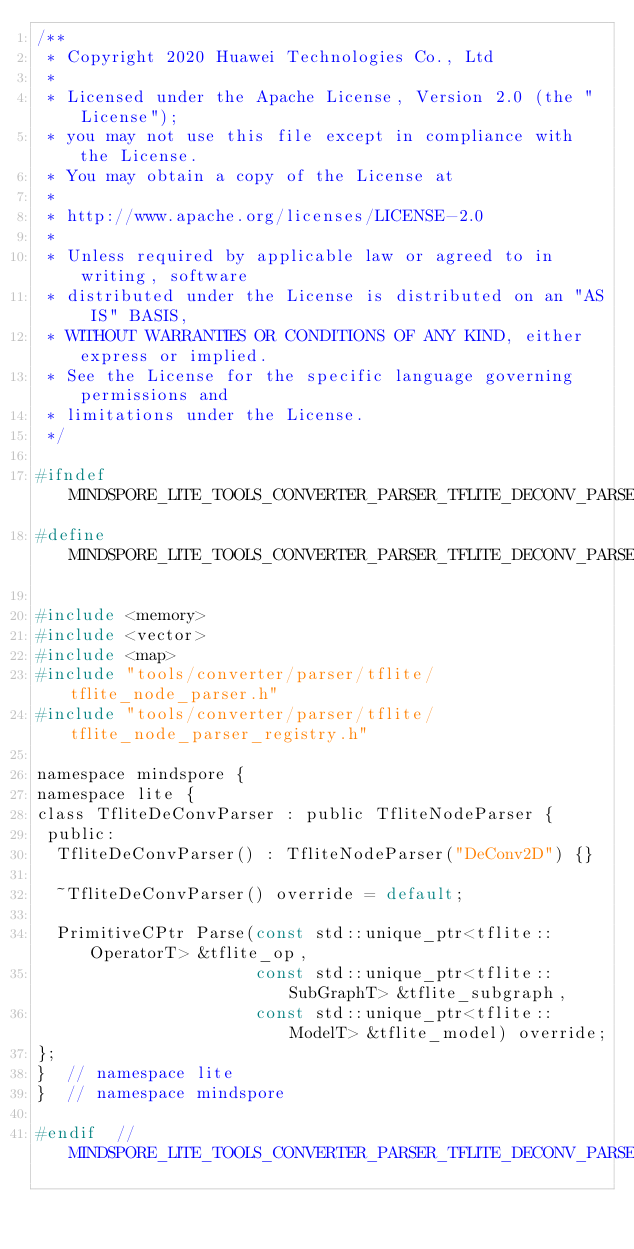<code> <loc_0><loc_0><loc_500><loc_500><_C_>/**
 * Copyright 2020 Huawei Technologies Co., Ltd
 *
 * Licensed under the Apache License, Version 2.0 (the "License");
 * you may not use this file except in compliance with the License.
 * You may obtain a copy of the License at
 *
 * http://www.apache.org/licenses/LICENSE-2.0
 *
 * Unless required by applicable law or agreed to in writing, software
 * distributed under the License is distributed on an "AS IS" BASIS,
 * WITHOUT WARRANTIES OR CONDITIONS OF ANY KIND, either express or implied.
 * See the License for the specific language governing permissions and
 * limitations under the License.
 */

#ifndef MINDSPORE_LITE_TOOLS_CONVERTER_PARSER_TFLITE_DECONV_PARSER_H
#define MINDSPORE_LITE_TOOLS_CONVERTER_PARSER_TFLITE_DECONV_PARSER_H

#include <memory>
#include <vector>
#include <map>
#include "tools/converter/parser/tflite/tflite_node_parser.h"
#include "tools/converter/parser/tflite/tflite_node_parser_registry.h"

namespace mindspore {
namespace lite {
class TfliteDeConvParser : public TfliteNodeParser {
 public:
  TfliteDeConvParser() : TfliteNodeParser("DeConv2D") {}

  ~TfliteDeConvParser() override = default;

  PrimitiveCPtr Parse(const std::unique_ptr<tflite::OperatorT> &tflite_op,
                      const std::unique_ptr<tflite::SubGraphT> &tflite_subgraph,
                      const std::unique_ptr<tflite::ModelT> &tflite_model) override;
};
}  // namespace lite
}  // namespace mindspore

#endif  // MINDSPORE_LITE_TOOLS_CONVERTER_PARSER_TFLITE_DECONV_PARSER_H
</code> 